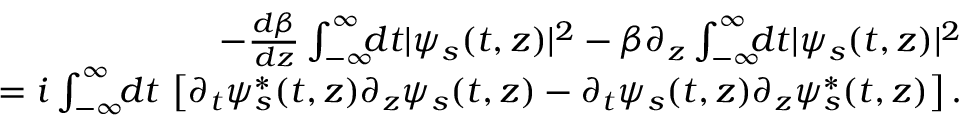Convert formula to latex. <formula><loc_0><loc_0><loc_500><loc_500>\begin{array} { r l r } & { \, - \frac { d \beta } { d z } \int _ { - \infty } ^ { \infty } \, d t | \psi _ { s } ( t , z ) | ^ { 2 } - \beta \partial _ { z } \int _ { - \infty } ^ { \infty } \, d t | \psi _ { s } ( t , z ) | ^ { 2 } } \\ & { = i \int _ { - \infty } ^ { \infty } \, d t \, \left [ \partial _ { t } \psi _ { s } ^ { * } ( t , z ) \partial _ { z } \psi _ { s } ( t , z ) - \partial _ { t } \psi _ { s } ( t , z ) \partial _ { z } \psi _ { s } ^ { * } ( t , z ) \right ] . } \end{array}</formula> 